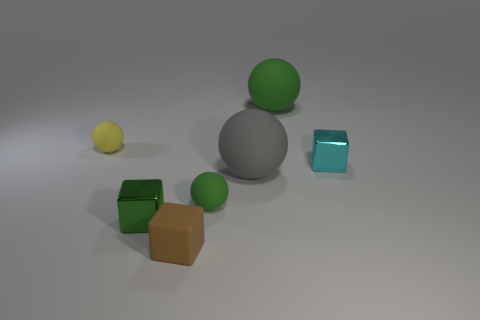Are there any other things that are the same shape as the big green thing?
Offer a very short reply. Yes. Is the number of large green objects less than the number of tiny blue objects?
Ensure brevity in your answer.  No. There is a small shiny block behind the green object on the left side of the small brown cube; what is its color?
Give a very brief answer. Cyan. The sphere to the left of the small matte object that is in front of the green sphere in front of the cyan shiny cube is made of what material?
Offer a terse response. Rubber. There is a rubber object that is left of the green shiny thing; is it the same size as the green block?
Offer a terse response. Yes. What material is the block that is behind the big gray sphere?
Give a very brief answer. Metal. Is the number of small green matte things greater than the number of purple metal cylinders?
Your answer should be very brief. Yes. What number of objects are either cyan things behind the gray object or matte balls?
Your response must be concise. 5. How many matte cubes are in front of the shiny cube behind the gray ball?
Your answer should be very brief. 1. What is the size of the metallic thing right of the small green shiny block that is in front of the small ball that is behind the cyan metallic cube?
Ensure brevity in your answer.  Small. 